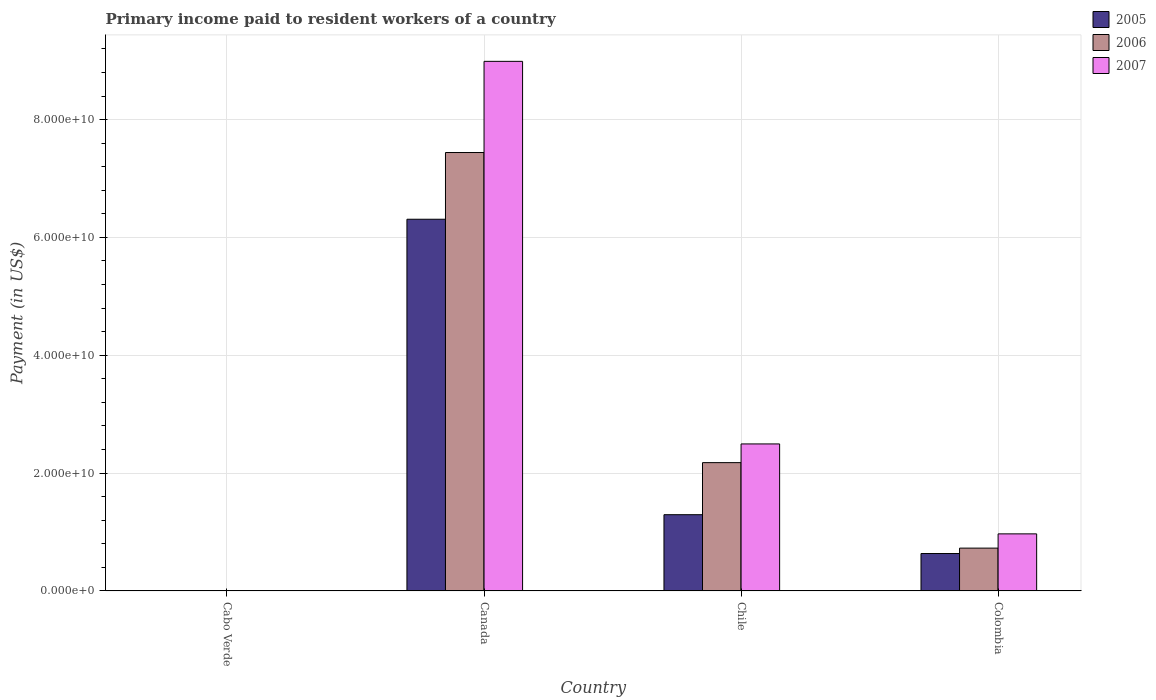How many different coloured bars are there?
Ensure brevity in your answer.  3. Are the number of bars on each tick of the X-axis equal?
Make the answer very short. Yes. How many bars are there on the 3rd tick from the left?
Provide a succinct answer. 3. What is the amount paid to workers in 2007 in Colombia?
Your answer should be very brief. 9.68e+09. Across all countries, what is the maximum amount paid to workers in 2005?
Your answer should be very brief. 6.31e+1. Across all countries, what is the minimum amount paid to workers in 2006?
Your answer should be compact. 5.94e+07. In which country was the amount paid to workers in 2005 maximum?
Provide a short and direct response. Canada. In which country was the amount paid to workers in 2006 minimum?
Make the answer very short. Cabo Verde. What is the total amount paid to workers in 2005 in the graph?
Keep it short and to the point. 8.24e+1. What is the difference between the amount paid to workers in 2007 in Canada and that in Chile?
Offer a very short reply. 6.49e+1. What is the difference between the amount paid to workers in 2006 in Colombia and the amount paid to workers in 2007 in Canada?
Give a very brief answer. -8.26e+1. What is the average amount paid to workers in 2006 per country?
Provide a short and direct response. 2.59e+1. What is the difference between the amount paid to workers of/in 2005 and amount paid to workers of/in 2006 in Canada?
Make the answer very short. -1.13e+1. What is the ratio of the amount paid to workers in 2007 in Canada to that in Chile?
Provide a succinct answer. 3.6. What is the difference between the highest and the second highest amount paid to workers in 2007?
Give a very brief answer. 1.53e+1. What is the difference between the highest and the lowest amount paid to workers in 2006?
Ensure brevity in your answer.  7.43e+1. What is the difference between two consecutive major ticks on the Y-axis?
Provide a short and direct response. 2.00e+1. Are the values on the major ticks of Y-axis written in scientific E-notation?
Offer a very short reply. Yes. Does the graph contain any zero values?
Give a very brief answer. No. Does the graph contain grids?
Keep it short and to the point. Yes. Where does the legend appear in the graph?
Your response must be concise. Top right. How many legend labels are there?
Ensure brevity in your answer.  3. What is the title of the graph?
Make the answer very short. Primary income paid to resident workers of a country. Does "1978" appear as one of the legend labels in the graph?
Ensure brevity in your answer.  No. What is the label or title of the Y-axis?
Provide a short and direct response. Payment (in US$). What is the Payment (in US$) of 2005 in Cabo Verde?
Give a very brief answer. 5.27e+07. What is the Payment (in US$) in 2006 in Cabo Verde?
Your answer should be very brief. 5.94e+07. What is the Payment (in US$) of 2007 in Cabo Verde?
Make the answer very short. 5.89e+07. What is the Payment (in US$) in 2005 in Canada?
Provide a short and direct response. 6.31e+1. What is the Payment (in US$) in 2006 in Canada?
Your answer should be compact. 7.44e+1. What is the Payment (in US$) in 2007 in Canada?
Your response must be concise. 8.99e+1. What is the Payment (in US$) of 2005 in Chile?
Make the answer very short. 1.29e+1. What is the Payment (in US$) in 2006 in Chile?
Provide a short and direct response. 2.18e+1. What is the Payment (in US$) in 2007 in Chile?
Ensure brevity in your answer.  2.49e+1. What is the Payment (in US$) of 2005 in Colombia?
Make the answer very short. 6.35e+09. What is the Payment (in US$) in 2006 in Colombia?
Give a very brief answer. 7.27e+09. What is the Payment (in US$) in 2007 in Colombia?
Provide a succinct answer. 9.68e+09. Across all countries, what is the maximum Payment (in US$) of 2005?
Provide a succinct answer. 6.31e+1. Across all countries, what is the maximum Payment (in US$) of 2006?
Make the answer very short. 7.44e+1. Across all countries, what is the maximum Payment (in US$) in 2007?
Ensure brevity in your answer.  8.99e+1. Across all countries, what is the minimum Payment (in US$) of 2005?
Provide a short and direct response. 5.27e+07. Across all countries, what is the minimum Payment (in US$) of 2006?
Offer a terse response. 5.94e+07. Across all countries, what is the minimum Payment (in US$) of 2007?
Provide a succinct answer. 5.89e+07. What is the total Payment (in US$) of 2005 in the graph?
Keep it short and to the point. 8.24e+1. What is the total Payment (in US$) of 2006 in the graph?
Keep it short and to the point. 1.04e+11. What is the total Payment (in US$) of 2007 in the graph?
Keep it short and to the point. 1.25e+11. What is the difference between the Payment (in US$) in 2005 in Cabo Verde and that in Canada?
Keep it short and to the point. -6.30e+1. What is the difference between the Payment (in US$) in 2006 in Cabo Verde and that in Canada?
Give a very brief answer. -7.43e+1. What is the difference between the Payment (in US$) in 2007 in Cabo Verde and that in Canada?
Ensure brevity in your answer.  -8.98e+1. What is the difference between the Payment (in US$) in 2005 in Cabo Verde and that in Chile?
Offer a terse response. -1.29e+1. What is the difference between the Payment (in US$) of 2006 in Cabo Verde and that in Chile?
Your response must be concise. -2.17e+1. What is the difference between the Payment (in US$) of 2007 in Cabo Verde and that in Chile?
Your response must be concise. -2.49e+1. What is the difference between the Payment (in US$) in 2005 in Cabo Verde and that in Colombia?
Your response must be concise. -6.30e+09. What is the difference between the Payment (in US$) of 2006 in Cabo Verde and that in Colombia?
Offer a very short reply. -7.21e+09. What is the difference between the Payment (in US$) in 2007 in Cabo Verde and that in Colombia?
Keep it short and to the point. -9.62e+09. What is the difference between the Payment (in US$) of 2005 in Canada and that in Chile?
Ensure brevity in your answer.  5.01e+1. What is the difference between the Payment (in US$) of 2006 in Canada and that in Chile?
Your response must be concise. 5.26e+1. What is the difference between the Payment (in US$) in 2007 in Canada and that in Chile?
Offer a terse response. 6.49e+1. What is the difference between the Payment (in US$) in 2005 in Canada and that in Colombia?
Ensure brevity in your answer.  5.67e+1. What is the difference between the Payment (in US$) in 2006 in Canada and that in Colombia?
Your response must be concise. 6.71e+1. What is the difference between the Payment (in US$) of 2007 in Canada and that in Colombia?
Your answer should be compact. 8.02e+1. What is the difference between the Payment (in US$) in 2005 in Chile and that in Colombia?
Offer a terse response. 6.59e+09. What is the difference between the Payment (in US$) of 2006 in Chile and that in Colombia?
Give a very brief answer. 1.45e+1. What is the difference between the Payment (in US$) of 2007 in Chile and that in Colombia?
Offer a very short reply. 1.53e+1. What is the difference between the Payment (in US$) of 2005 in Cabo Verde and the Payment (in US$) of 2006 in Canada?
Provide a succinct answer. -7.44e+1. What is the difference between the Payment (in US$) of 2005 in Cabo Verde and the Payment (in US$) of 2007 in Canada?
Give a very brief answer. -8.98e+1. What is the difference between the Payment (in US$) of 2006 in Cabo Verde and the Payment (in US$) of 2007 in Canada?
Provide a succinct answer. -8.98e+1. What is the difference between the Payment (in US$) in 2005 in Cabo Verde and the Payment (in US$) in 2006 in Chile?
Ensure brevity in your answer.  -2.17e+1. What is the difference between the Payment (in US$) of 2005 in Cabo Verde and the Payment (in US$) of 2007 in Chile?
Provide a short and direct response. -2.49e+1. What is the difference between the Payment (in US$) in 2006 in Cabo Verde and the Payment (in US$) in 2007 in Chile?
Make the answer very short. -2.49e+1. What is the difference between the Payment (in US$) of 2005 in Cabo Verde and the Payment (in US$) of 2006 in Colombia?
Your answer should be compact. -7.21e+09. What is the difference between the Payment (in US$) in 2005 in Cabo Verde and the Payment (in US$) in 2007 in Colombia?
Your answer should be very brief. -9.63e+09. What is the difference between the Payment (in US$) of 2006 in Cabo Verde and the Payment (in US$) of 2007 in Colombia?
Your answer should be compact. -9.62e+09. What is the difference between the Payment (in US$) of 2005 in Canada and the Payment (in US$) of 2006 in Chile?
Your answer should be compact. 4.13e+1. What is the difference between the Payment (in US$) in 2005 in Canada and the Payment (in US$) in 2007 in Chile?
Your response must be concise. 3.81e+1. What is the difference between the Payment (in US$) of 2006 in Canada and the Payment (in US$) of 2007 in Chile?
Make the answer very short. 4.95e+1. What is the difference between the Payment (in US$) of 2005 in Canada and the Payment (in US$) of 2006 in Colombia?
Make the answer very short. 5.58e+1. What is the difference between the Payment (in US$) of 2005 in Canada and the Payment (in US$) of 2007 in Colombia?
Your answer should be compact. 5.34e+1. What is the difference between the Payment (in US$) in 2006 in Canada and the Payment (in US$) in 2007 in Colombia?
Provide a succinct answer. 6.47e+1. What is the difference between the Payment (in US$) of 2005 in Chile and the Payment (in US$) of 2006 in Colombia?
Offer a terse response. 5.67e+09. What is the difference between the Payment (in US$) in 2005 in Chile and the Payment (in US$) in 2007 in Colombia?
Keep it short and to the point. 3.26e+09. What is the difference between the Payment (in US$) in 2006 in Chile and the Payment (in US$) in 2007 in Colombia?
Your response must be concise. 1.21e+1. What is the average Payment (in US$) in 2005 per country?
Offer a terse response. 2.06e+1. What is the average Payment (in US$) in 2006 per country?
Your answer should be very brief. 2.59e+1. What is the average Payment (in US$) in 2007 per country?
Keep it short and to the point. 3.11e+1. What is the difference between the Payment (in US$) of 2005 and Payment (in US$) of 2006 in Cabo Verde?
Offer a very short reply. -6.69e+06. What is the difference between the Payment (in US$) in 2005 and Payment (in US$) in 2007 in Cabo Verde?
Offer a terse response. -6.20e+06. What is the difference between the Payment (in US$) of 2006 and Payment (in US$) of 2007 in Cabo Verde?
Your response must be concise. 4.88e+05. What is the difference between the Payment (in US$) in 2005 and Payment (in US$) in 2006 in Canada?
Offer a very short reply. -1.13e+1. What is the difference between the Payment (in US$) in 2005 and Payment (in US$) in 2007 in Canada?
Make the answer very short. -2.68e+1. What is the difference between the Payment (in US$) of 2006 and Payment (in US$) of 2007 in Canada?
Provide a succinct answer. -1.55e+1. What is the difference between the Payment (in US$) of 2005 and Payment (in US$) of 2006 in Chile?
Make the answer very short. -8.84e+09. What is the difference between the Payment (in US$) of 2005 and Payment (in US$) of 2007 in Chile?
Ensure brevity in your answer.  -1.20e+1. What is the difference between the Payment (in US$) of 2006 and Payment (in US$) of 2007 in Chile?
Offer a very short reply. -3.17e+09. What is the difference between the Payment (in US$) of 2005 and Payment (in US$) of 2006 in Colombia?
Your answer should be compact. -9.18e+08. What is the difference between the Payment (in US$) of 2005 and Payment (in US$) of 2007 in Colombia?
Ensure brevity in your answer.  -3.34e+09. What is the difference between the Payment (in US$) of 2006 and Payment (in US$) of 2007 in Colombia?
Ensure brevity in your answer.  -2.42e+09. What is the ratio of the Payment (in US$) in 2005 in Cabo Verde to that in Canada?
Offer a terse response. 0. What is the ratio of the Payment (in US$) of 2006 in Cabo Verde to that in Canada?
Offer a terse response. 0. What is the ratio of the Payment (in US$) in 2007 in Cabo Verde to that in Canada?
Ensure brevity in your answer.  0. What is the ratio of the Payment (in US$) in 2005 in Cabo Verde to that in Chile?
Provide a succinct answer. 0. What is the ratio of the Payment (in US$) of 2006 in Cabo Verde to that in Chile?
Ensure brevity in your answer.  0. What is the ratio of the Payment (in US$) in 2007 in Cabo Verde to that in Chile?
Provide a succinct answer. 0. What is the ratio of the Payment (in US$) in 2005 in Cabo Verde to that in Colombia?
Give a very brief answer. 0.01. What is the ratio of the Payment (in US$) of 2006 in Cabo Verde to that in Colombia?
Provide a short and direct response. 0.01. What is the ratio of the Payment (in US$) in 2007 in Cabo Verde to that in Colombia?
Keep it short and to the point. 0.01. What is the ratio of the Payment (in US$) of 2005 in Canada to that in Chile?
Keep it short and to the point. 4.88. What is the ratio of the Payment (in US$) of 2006 in Canada to that in Chile?
Offer a terse response. 3.42. What is the ratio of the Payment (in US$) of 2007 in Canada to that in Chile?
Make the answer very short. 3.6. What is the ratio of the Payment (in US$) in 2005 in Canada to that in Colombia?
Offer a terse response. 9.94. What is the ratio of the Payment (in US$) of 2006 in Canada to that in Colombia?
Your answer should be compact. 10.24. What is the ratio of the Payment (in US$) of 2007 in Canada to that in Colombia?
Provide a succinct answer. 9.28. What is the ratio of the Payment (in US$) in 2005 in Chile to that in Colombia?
Keep it short and to the point. 2.04. What is the ratio of the Payment (in US$) of 2006 in Chile to that in Colombia?
Give a very brief answer. 3. What is the ratio of the Payment (in US$) in 2007 in Chile to that in Colombia?
Your response must be concise. 2.58. What is the difference between the highest and the second highest Payment (in US$) of 2005?
Ensure brevity in your answer.  5.01e+1. What is the difference between the highest and the second highest Payment (in US$) of 2006?
Provide a short and direct response. 5.26e+1. What is the difference between the highest and the second highest Payment (in US$) of 2007?
Provide a succinct answer. 6.49e+1. What is the difference between the highest and the lowest Payment (in US$) of 2005?
Your answer should be compact. 6.30e+1. What is the difference between the highest and the lowest Payment (in US$) of 2006?
Keep it short and to the point. 7.43e+1. What is the difference between the highest and the lowest Payment (in US$) in 2007?
Offer a terse response. 8.98e+1. 